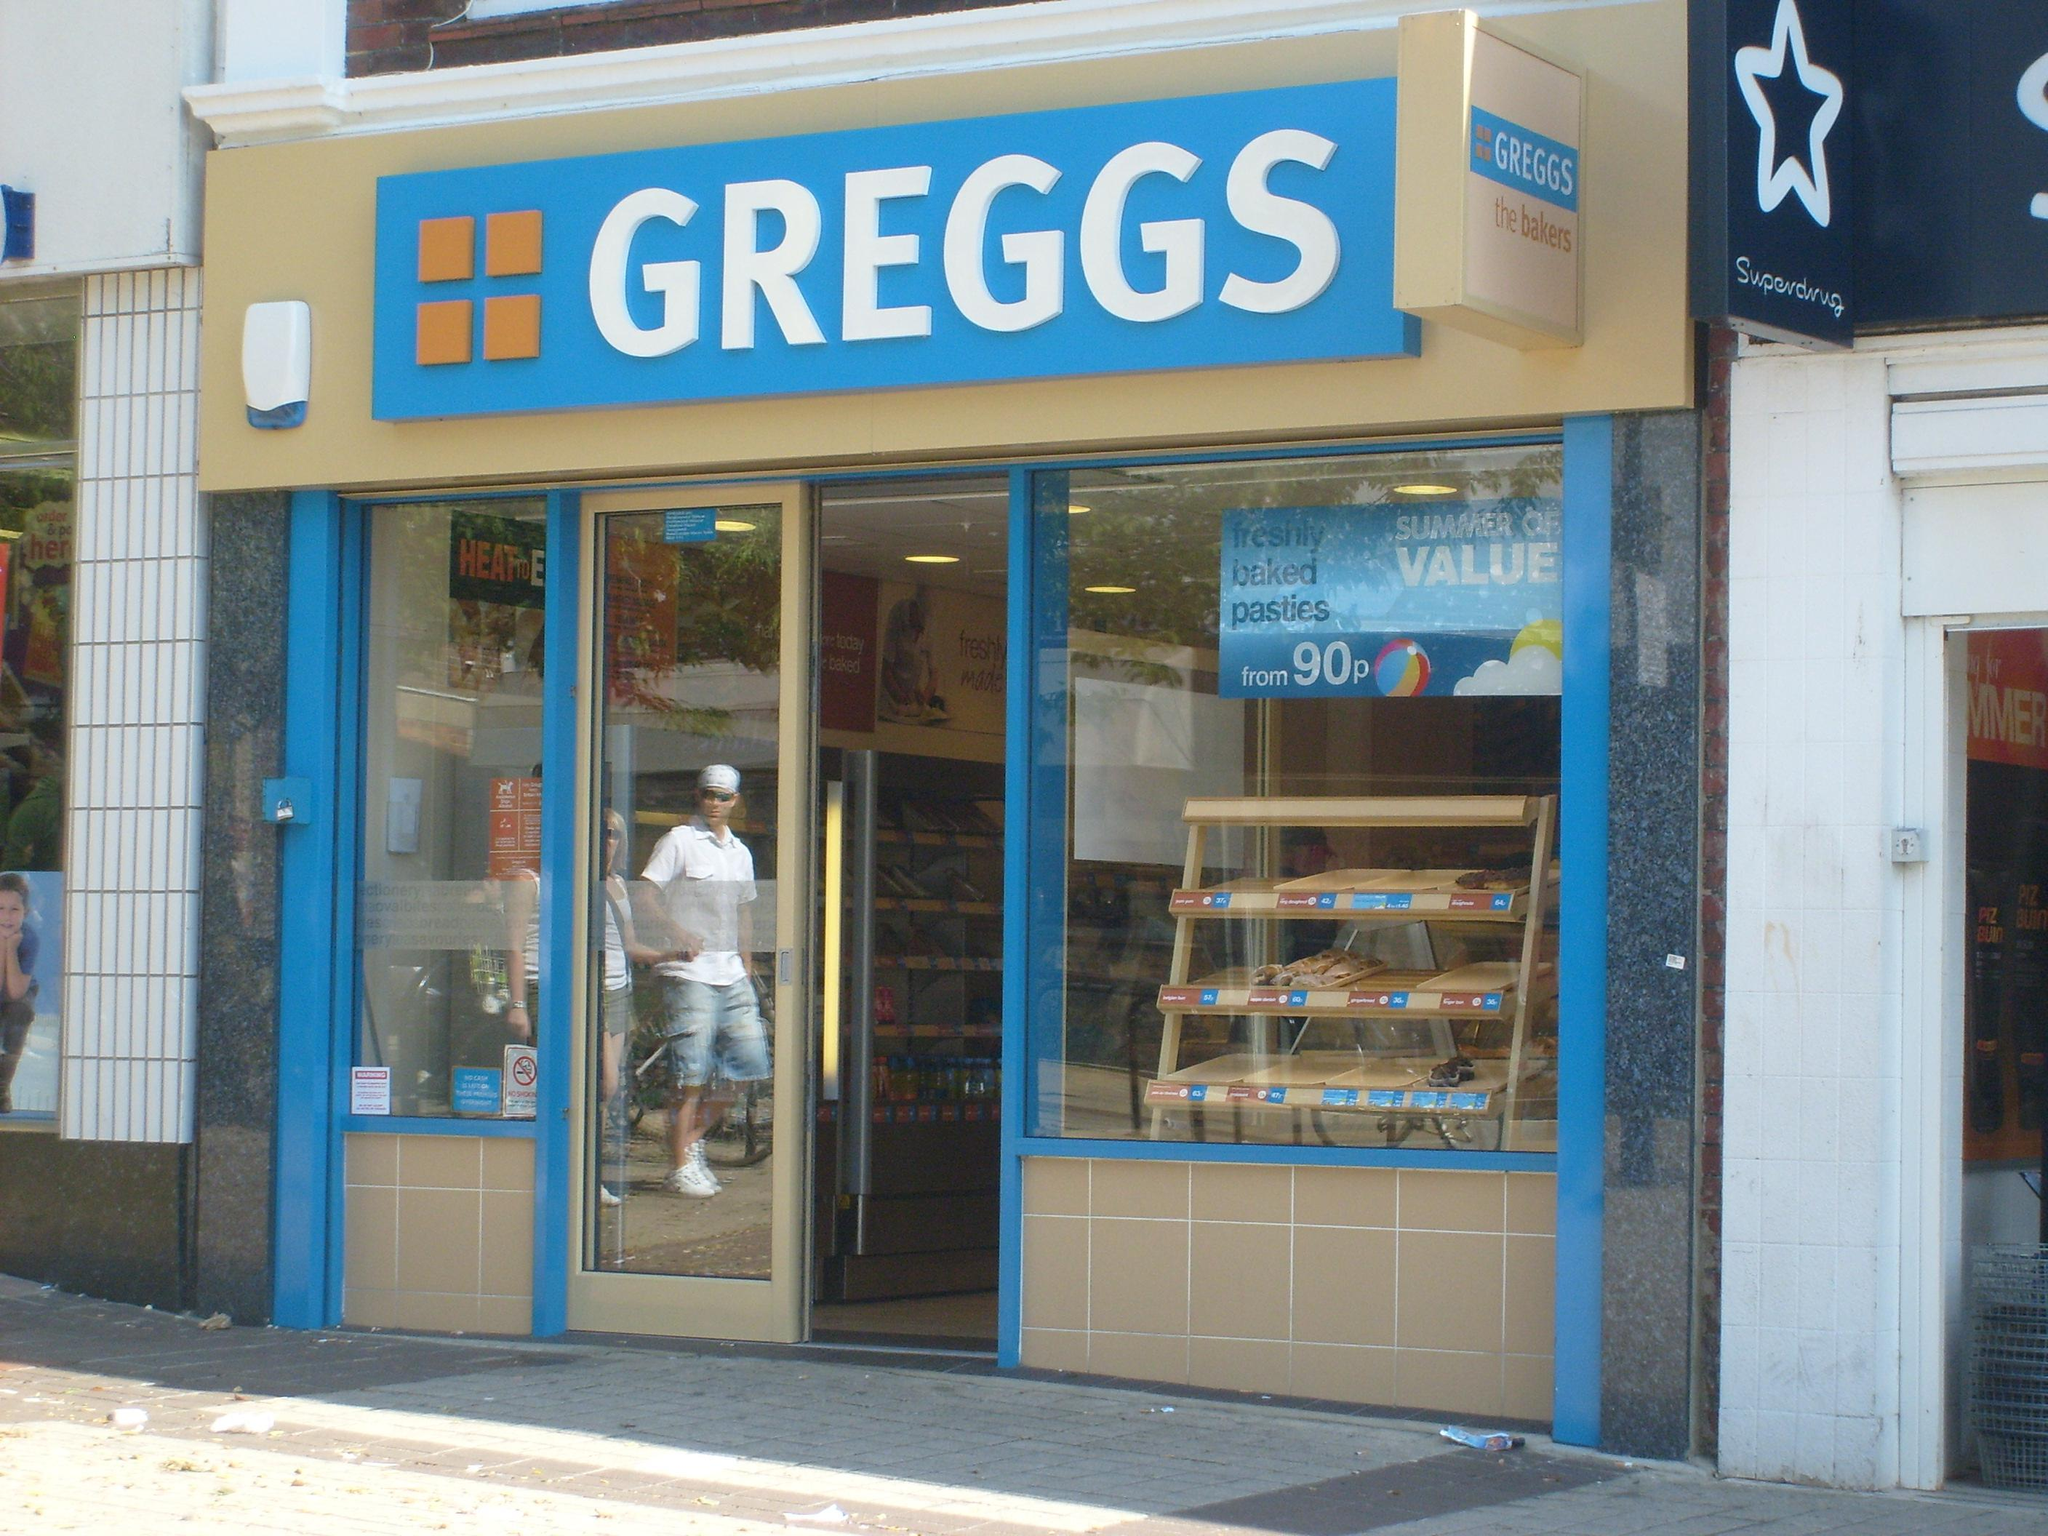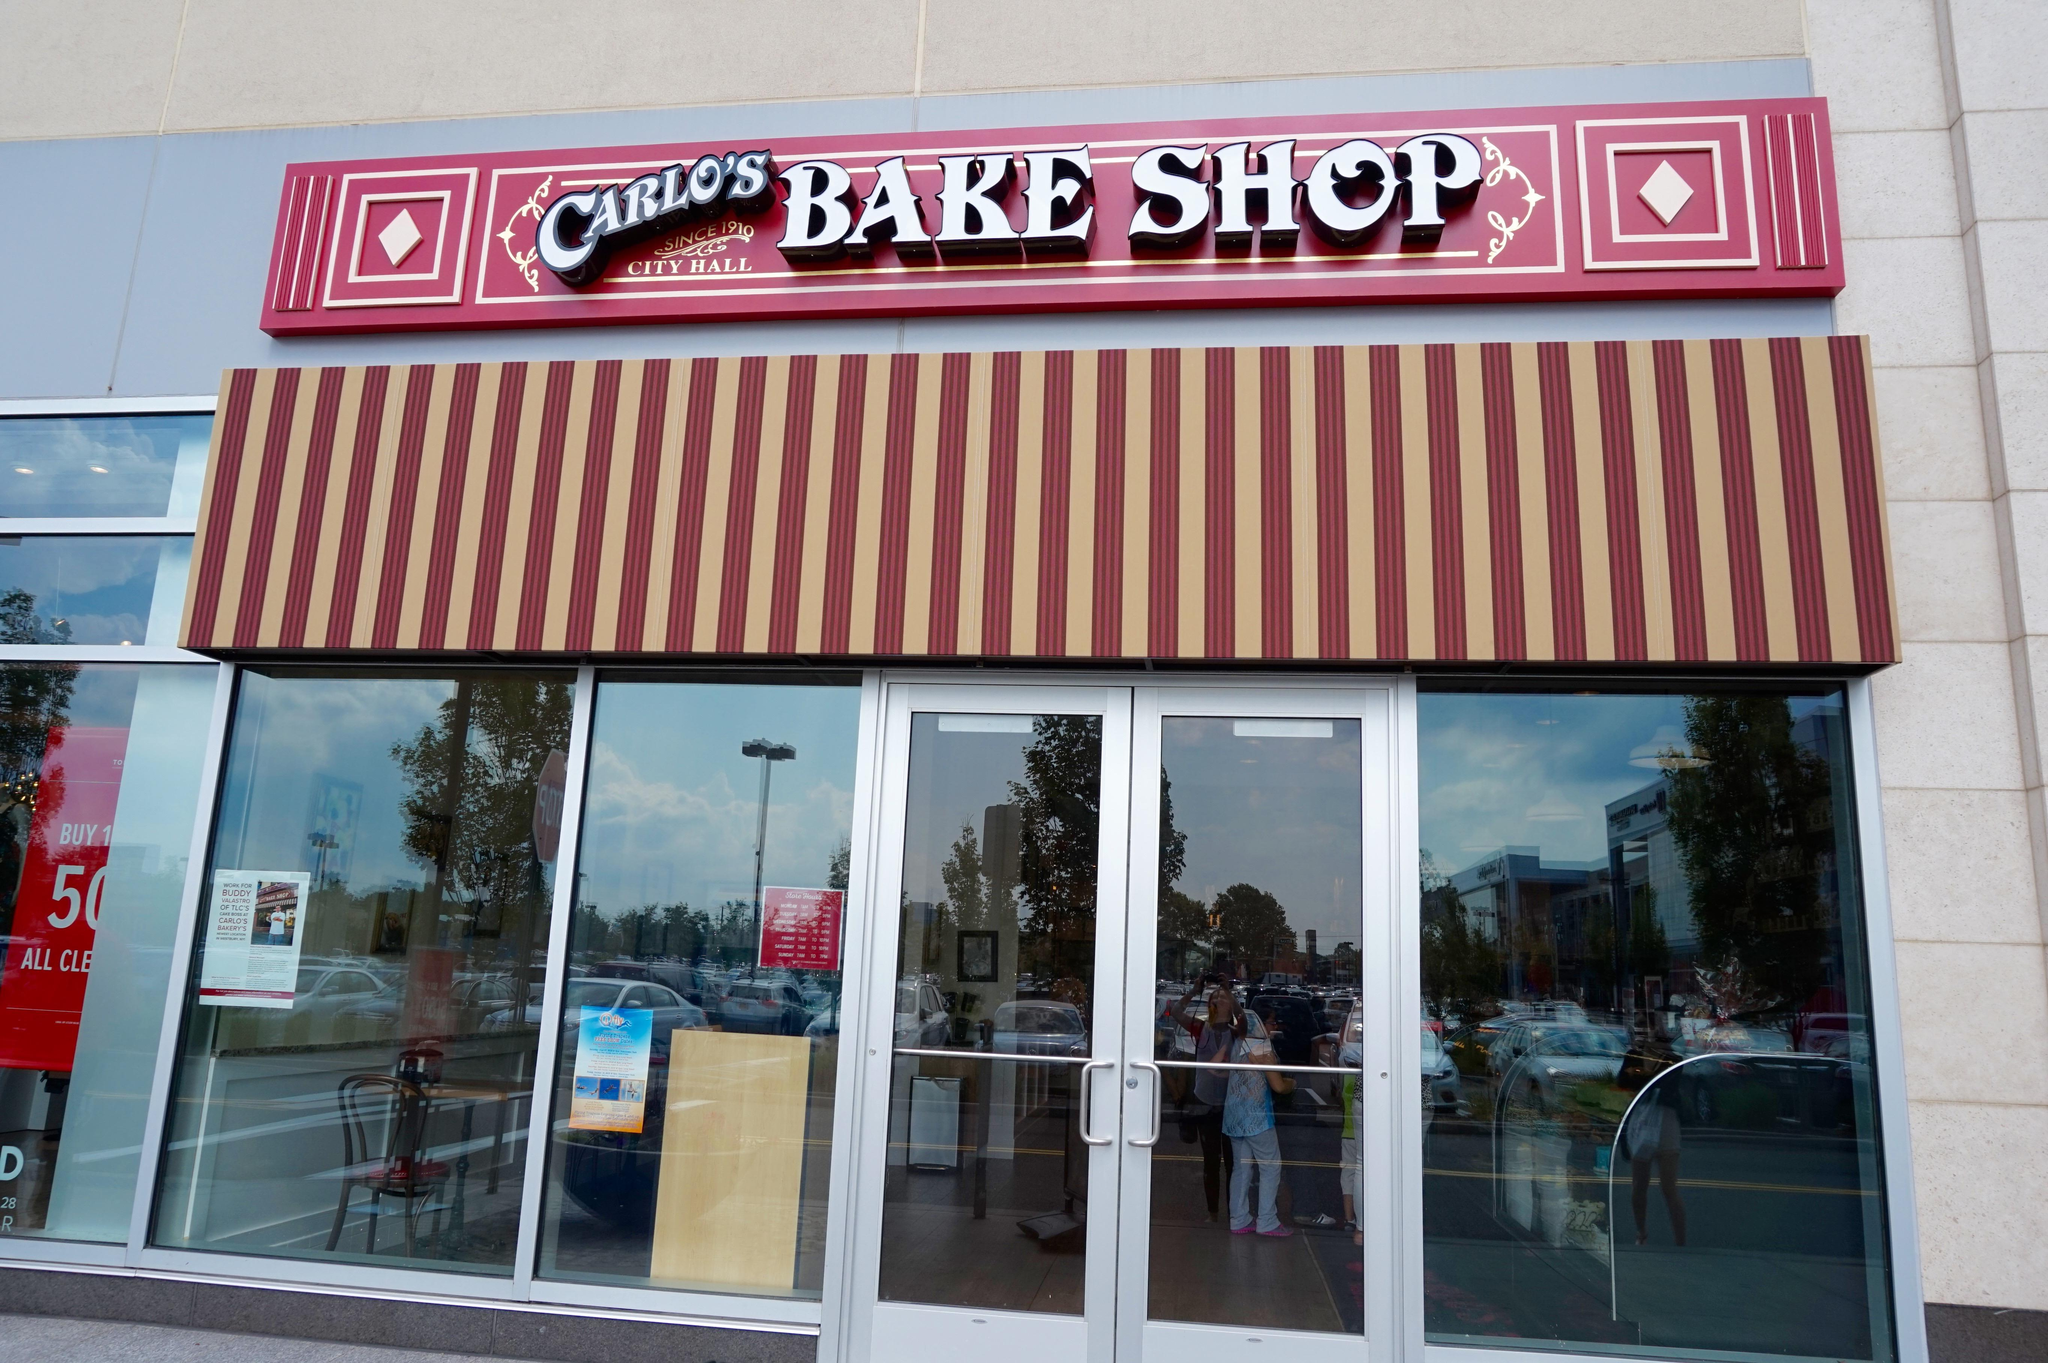The first image is the image on the left, the second image is the image on the right. For the images shown, is this caption "There is at least one person standing outside the store in the image on the right." true? Answer yes or no. No. 